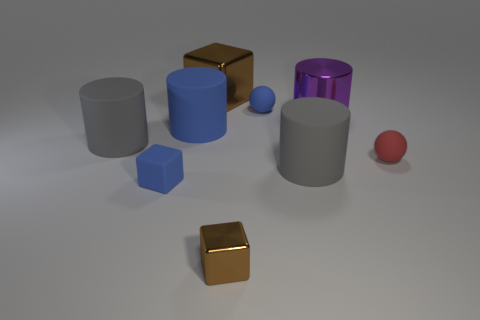What can you tell me about the lighting and shadows in this scene? The lighting in the scene is soft and diffused, coming from a direction that is slightly elevated above the horizon of the objects. This creates gentle shadows that extend to the right of the objects, suggesting that the primary light source is positioned to the left. The shadows are soft-edged and not too dark, which indicates the light source is not overly intense. The even lighting and mild shadows contribute to the calm and balanced atmosphere of the image. 